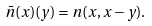Convert formula to latex. <formula><loc_0><loc_0><loc_500><loc_500>\bar { n } ( x ) ( y ) = n ( x , x - y ) .</formula> 